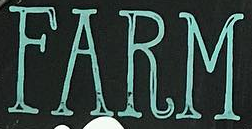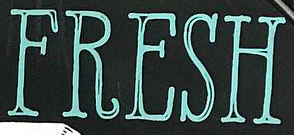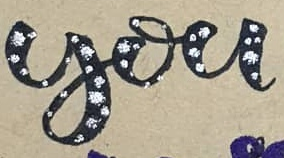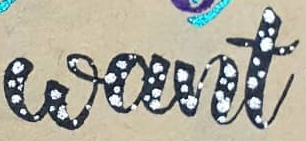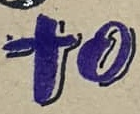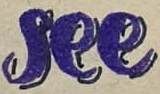What text appears in these images from left to right, separated by a semicolon? FARM; FRESH; you; want; to; see 